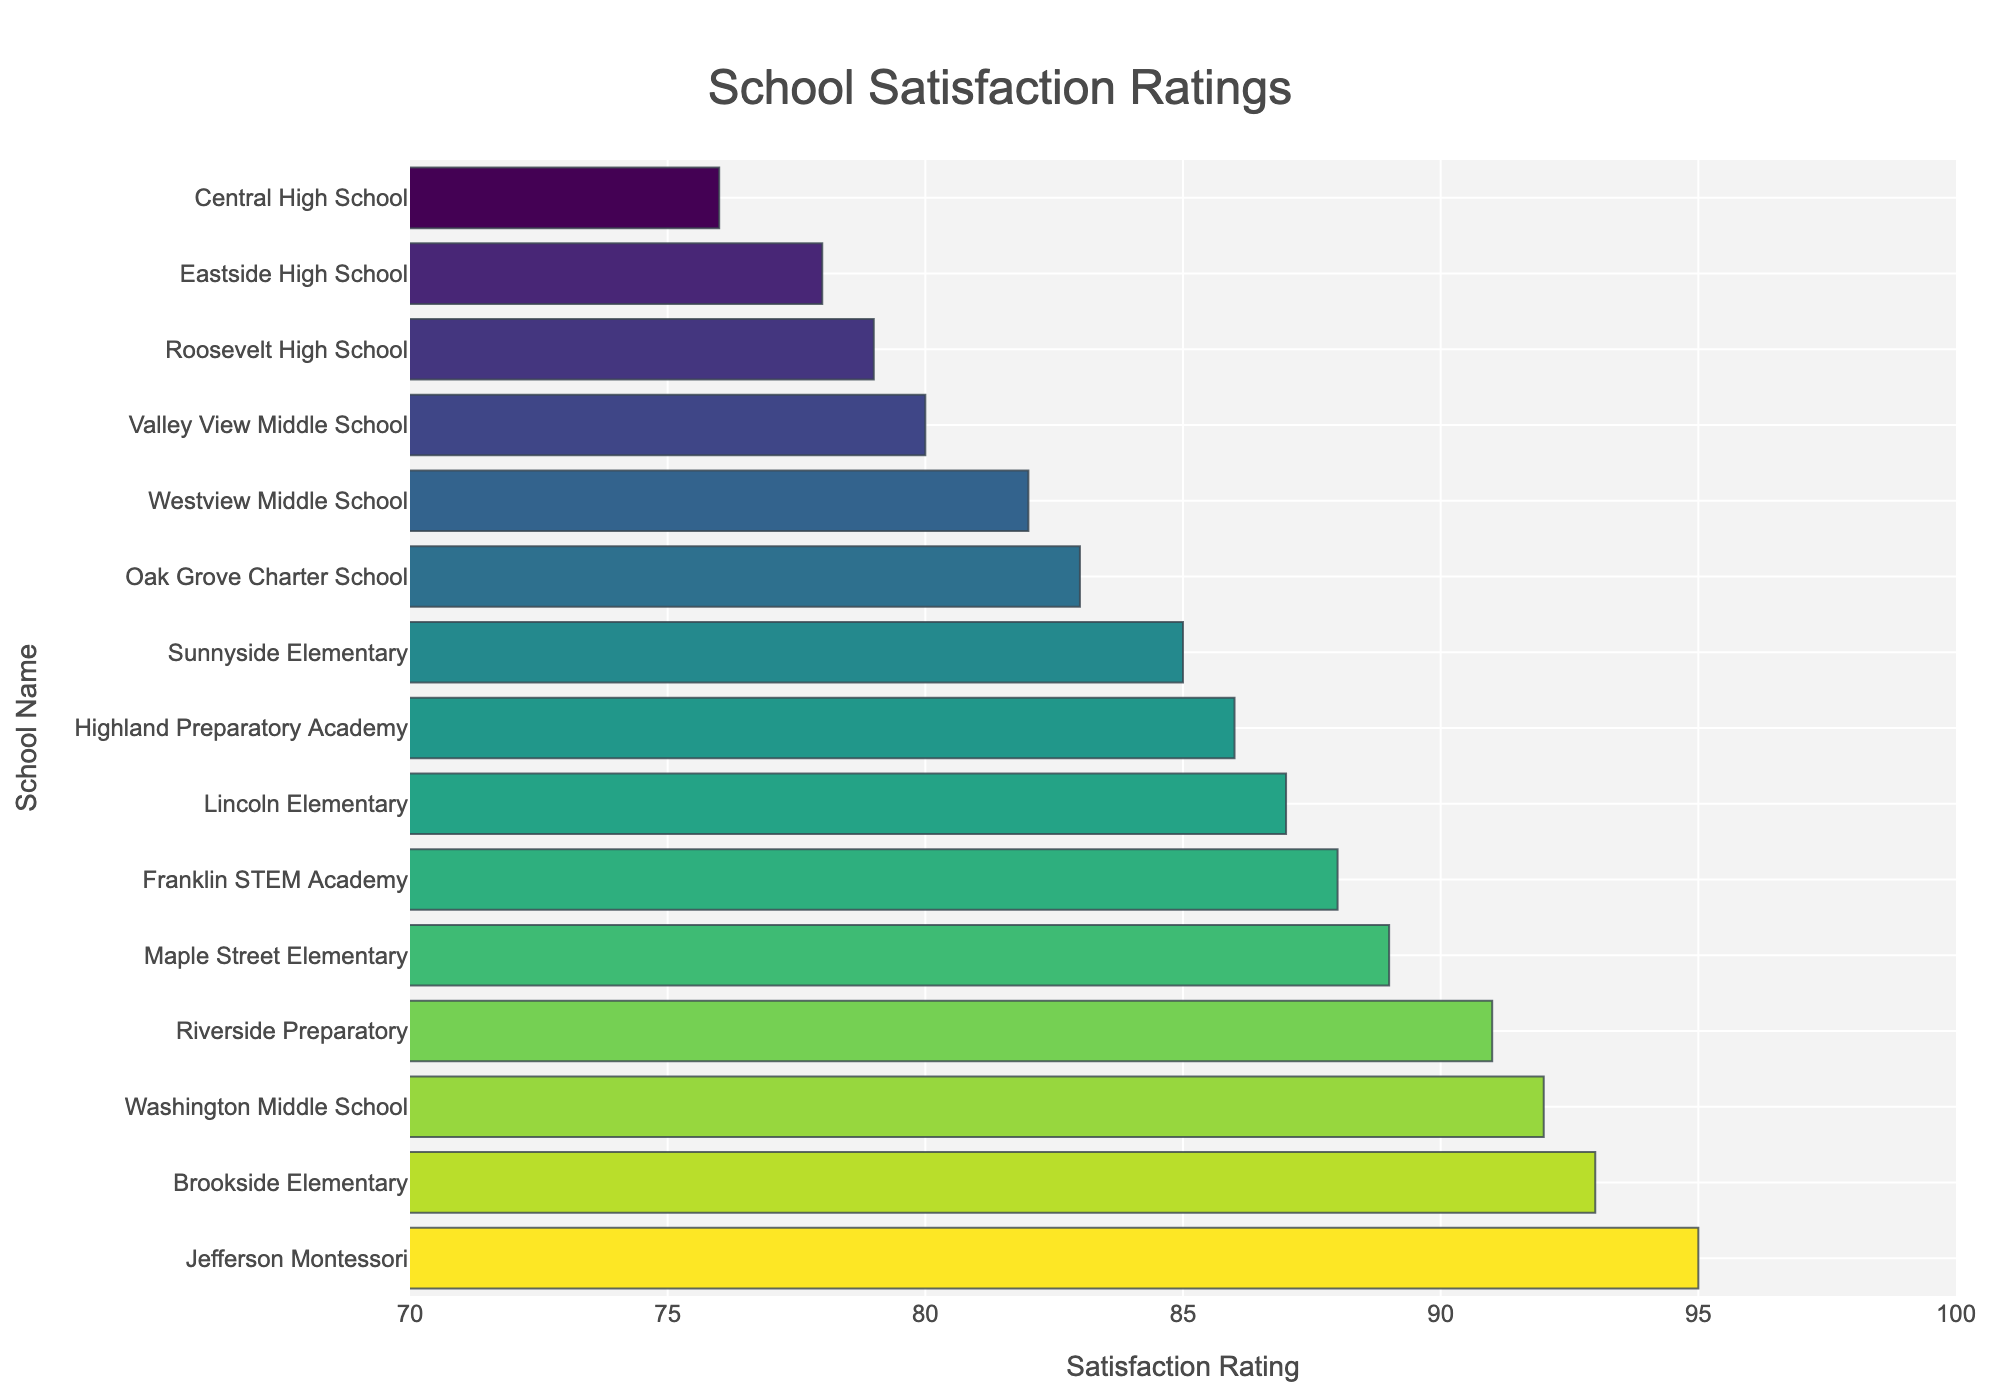Which school has the highest satisfaction rating? By looking at the bar corresponding to the highest value on the x-axis, we can see that Jefferson Montessori has the highest satisfaction rating.
Answer: Jefferson Montessori Which school has the lowest satisfaction rating? By identifying the bar with the lowest value on the x-axis, we find that Central High School has the lowest satisfaction rating.
Answer: Central High School What is the average satisfaction rating of all schools? To find the average satisfaction rating, add all the satisfaction ratings together and divide by the number of schools: (87 + 92 + 79 + 95 + 88 + 83 + 91 + 85 + 76 + 89 + 82 + 78 + 93 + 86 + 80) / 15 = 85.
Answer: 85 Which schools have satisfaction ratings greater than 90? Identify all bars with values greater than 90 on the x-axis: Jefferson Montessori (95), Washington Middle School (92), Riverside Preparatory (91), and Brookside Elementary (93).
Answer: Jefferson Montessori, Washington Middle School, Riverside Preparatory, Brookside Elementary How many schools have a satisfaction rating between 80 and 90? Count the number of bars whose values fall within the range of 80 to 90, inclusive: Lincoln Elementary (87), Franklin STEM Academy (88), Oak Grove Charter School (83), Sunnyside Elementary (85), Maple Street Elementary (89), Westview Middle School (82), Highland Preparatory Academy (86), Valley View Middle School (80).
Answer: 8 What is the difference in satisfaction rating between the highest and lowest-rated schools? Subtract the satisfaction rating of the lowest-rated school from that of the highest-rated school: 95 (Jefferson Montessori) - 76 (Central High School) = 19.
Answer: 19 Which school is rated higher, Lincoln Elementary or Maple Street Elementary? By comparing the bars' satisfaction ratings, we see that Lincoln Elementary has a rating of 87 and Maple Street Elementary has a rating of 89.
Answer: Maple Street Elementary What is the median satisfaction rating of the schools? To find the median, list the satisfaction ratings in ascending order and find the middle value: 76, 78, 79, 80, 82, 83, 85, 86, 87, 88, 89, 91, 92, 93, 95. The middle value in this list is 86.
Answer: 86 Which school has approximately the same satisfaction rating as Oak Grove Charter School? Oak Grove Charter School has a rating of 83. Riverside Preparatory has a rating close to 83, with 91.
Answer: Riverside Preparatory Which three schools have the satisfaction ratings closest together? Identify the three schools with the closest satisfaction ratings: Oak Grove Charter School (83), Westview Middle School (82), and Valley View Middle School (80).
Answer: Oak Grove Charter School, Westview Middle School, Valley View Middle School 